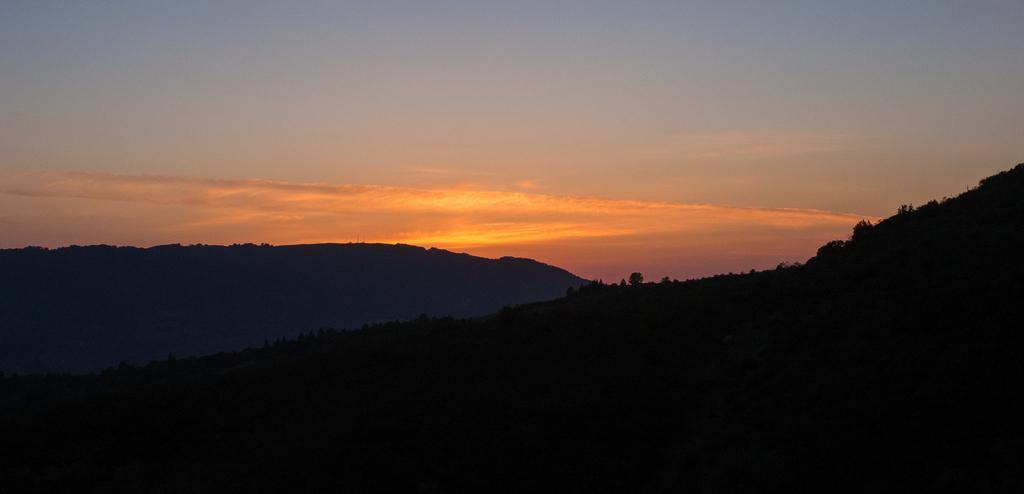Can you describe this image briefly? In this picture we can see mountains and trees. In the background we can see orange color clouds. At the top there is a sky. At the bottom we can see the darkness. 